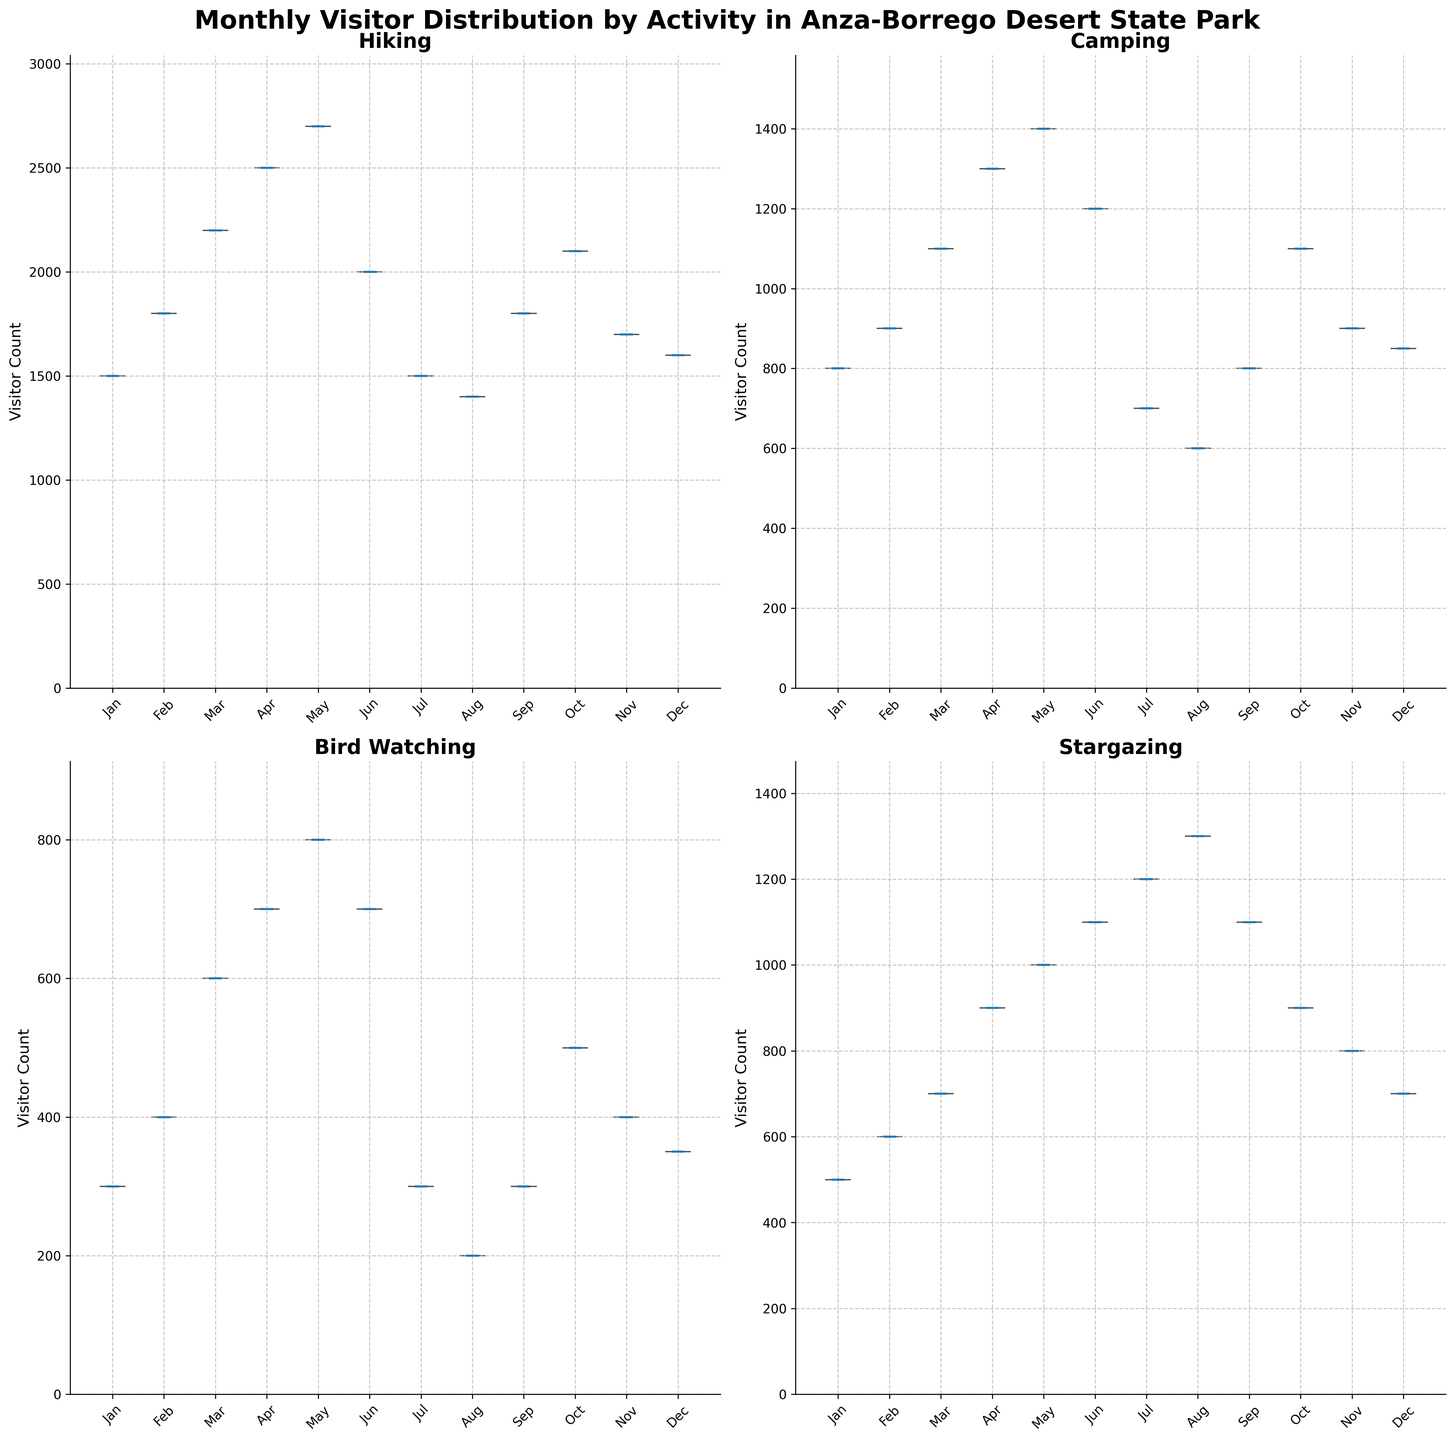What's the total number of visitor counts in April for all activities? Sum the visitor counts in April: hiking (2500) + camping (1300) + bird watching (700) + stargazing (900) = 5400
Answer: 5400 Which activity has the highest visitor count in December? Compare the December visitor counts for all activities: hiking (1600), camping (850), bird watching (350), and stargazing (700). Hiking has the highest count.
Answer: Hiking In which month does bird watching have its peak visitor count? Identify the month with the highest bird watching visitor count: March (600), April (700), May (800), February (400). May is the peak month with 800 visitors.
Answer: May Is there any month where the visitor count for camping exceeds 1000? Check each month's camping visitor count: January (800), February (900), March (1100), April (1300), May (1400), June (1200), October (1100). March, April, May, June, and October exceed 1000 visitors.
Answer: Yes Compare the visitor count patterns for hiking and camping. Which activity generally has more visitors? Compare monthly visitor counts: hiking (ranging 1400-2700) generally has higher counts compared to camping (ranging 600-1400).
Answer: Hiking Which month has the lowest visitor count for stargazing? Identify the month with the lowest visitor count for stargazing: July (1200), August (1300), September (1100), and December (700). December is the lowest.
Answer: December Across all activities, which month tends to have the lowest visitor counts? Identify the month with the lowest visitor counts across activities: January (hiking 1500, camping 800, bird watching 300, stargazing 500). January has the lowest counts.
Answer: January Do hiking visitor counts show a significant drop in any specific month? Identify any significant drops in monthly hiking counts: June (2000) to July (1500) shows a significant drop (2500 - 1500 = 500).
Answer: July What's the average visitor count per month for stargazing? Calculate the average: Sum of monthly stargazing counts is 10400, and there are 12 months, so average = 10400/12 ≈ 866.67
Answer: Approx. 867 